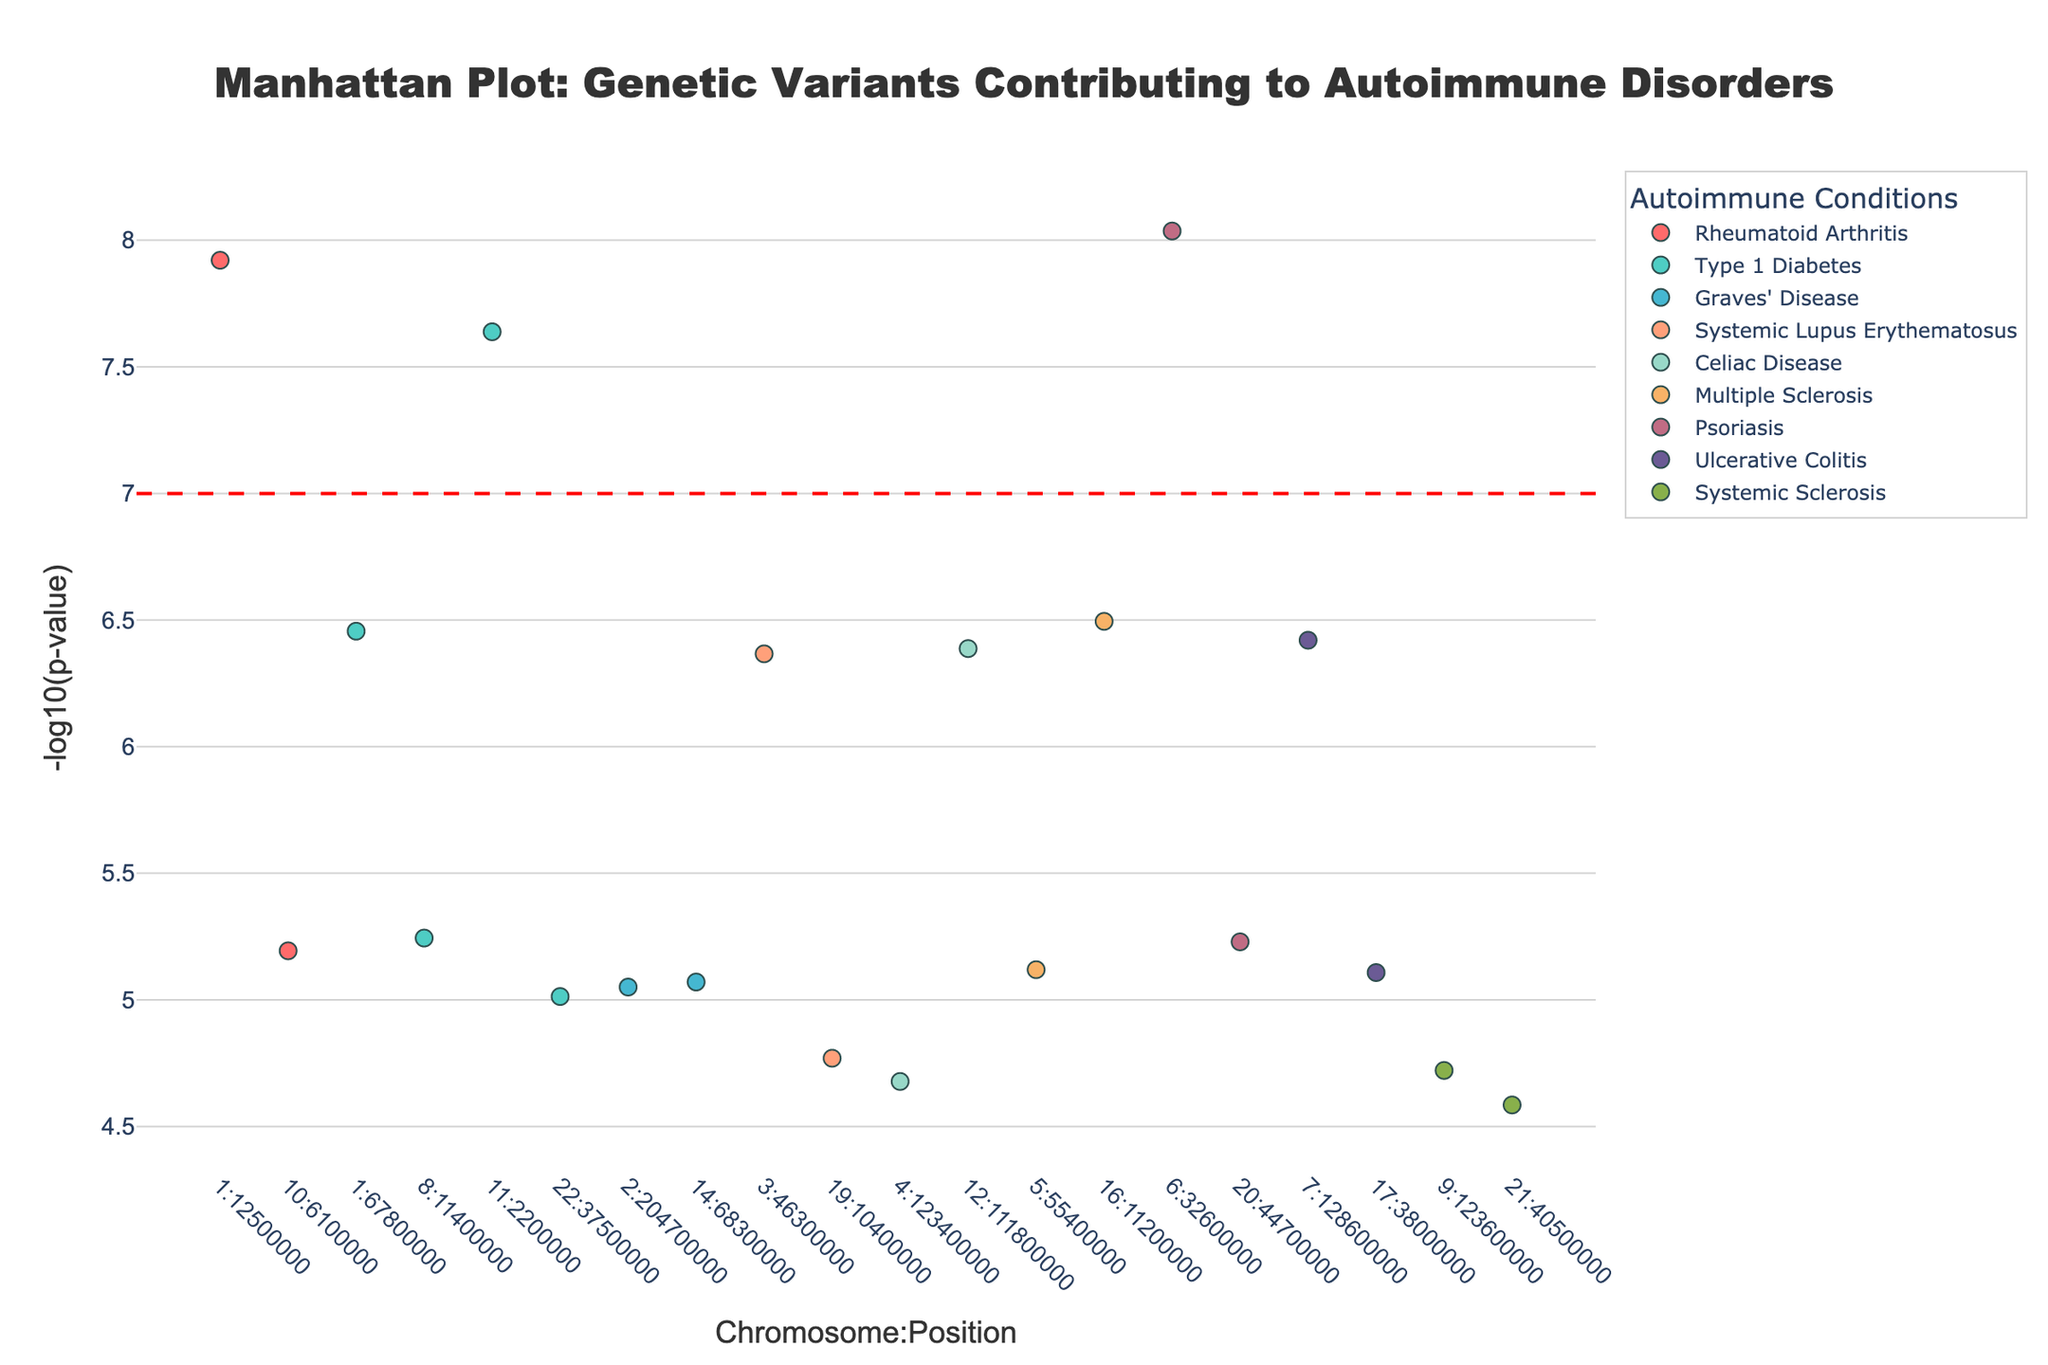What's the main focus of this Manhattan Plot? The title of the plot is "Manhattan Plot: Genetic Variants Contributing to Autoimmune Disorders." This indicates that the main focus is on identifying genetic variants associated with autoimmune conditions.
Answer: Genetic Variants Contributing to Autoimmune Disorders What does the y-axis represent in this plot? The y-axis represents the -log10(p-value), which measures the significance of the association between SNPs and autoimmune disorders. Higher values indicate more significant associations.
Answer: -log10(p-value) How many autoimmune conditions are depicted in this plot? There are nine distinct colors in the plot, each corresponding to a different autoimmune condition as shown in the legend.
Answer: Nine Which autoimmune condition has the SNP with the highest significance level, and what is its SNP identifier? The SNP with the highest significance level is represented by the highest point on the y-axis, which corresponds to -log10(p) of 9.2 at Chromosome 6. According to the hover information, the autoimmune condition is Psoriasis, and the SNP identifier is rs9268645.
Answer: Psoriasis, rs9268645 Identify two autoimmune conditions that share the same chromosome for their most significant SNPs. Both Celiac Disease and Type 1 Diabetes have their most significant SNPs on Chromosome 1, as indicated by examining the chromosome positions along the x-axis and matching the conditions listed in the legend.
Answer: Celiac Disease, Type 1 Diabetes Which SNP has the second lowest p-value, and to which autoimmune condition is it related? The second highest point on the y-axis corresponds to the second lowest p-value. It is at Chromosome 1 with -log10(p) of approximately 8. The related SNP is rs2476601, and the associated autoimmune condition is Rheumatoid Arthritis.
Answer: rs2476601, Rheumatoid Arthritis What's the minimum -log10(p-value) represented in the plot, and which condition does it belong to? The lowest point on the y-axis has a -log10(p-value) of around 4, which corresponds to a p-value of approximately 2.6e-05. This point belongs to Systemic Sclerosis.
Answer: 4, Systemic Sclerosis Compare the significance levels of SNPs rs6679677 and rs4728142. Which one is more significant, and by how much? SNP rs6679677 (after logarithmic conversion, appears at Chromosome 1) has a -log10(p) of about 6.5, while SNP rs4728142 (appears at Chromosome 7) has a -log10(p) of about 6.4. Therefore, rs6679677 is more significant by a slight margin of 0.1.
Answer: rs6679677, 0.1 Are there any conditions with multiple significant SNPs? If so, name the conditions and the SNPs. Type 1 Diabetes appears twice with significant SNPs rs6679677 and rs2104286, seen at Chromosome 1 and Chromosome 8. Similarly, Rheumatoid Arthritis also appears twice with significant SNPs rs2476601 and rs947474, at Chromosome 1 and Chromosome 10.
Answer: Type 1 Diabetes (rs6679677, rs2104286) and Rheumatoid Arthritis (rs2476601, rs947474) 